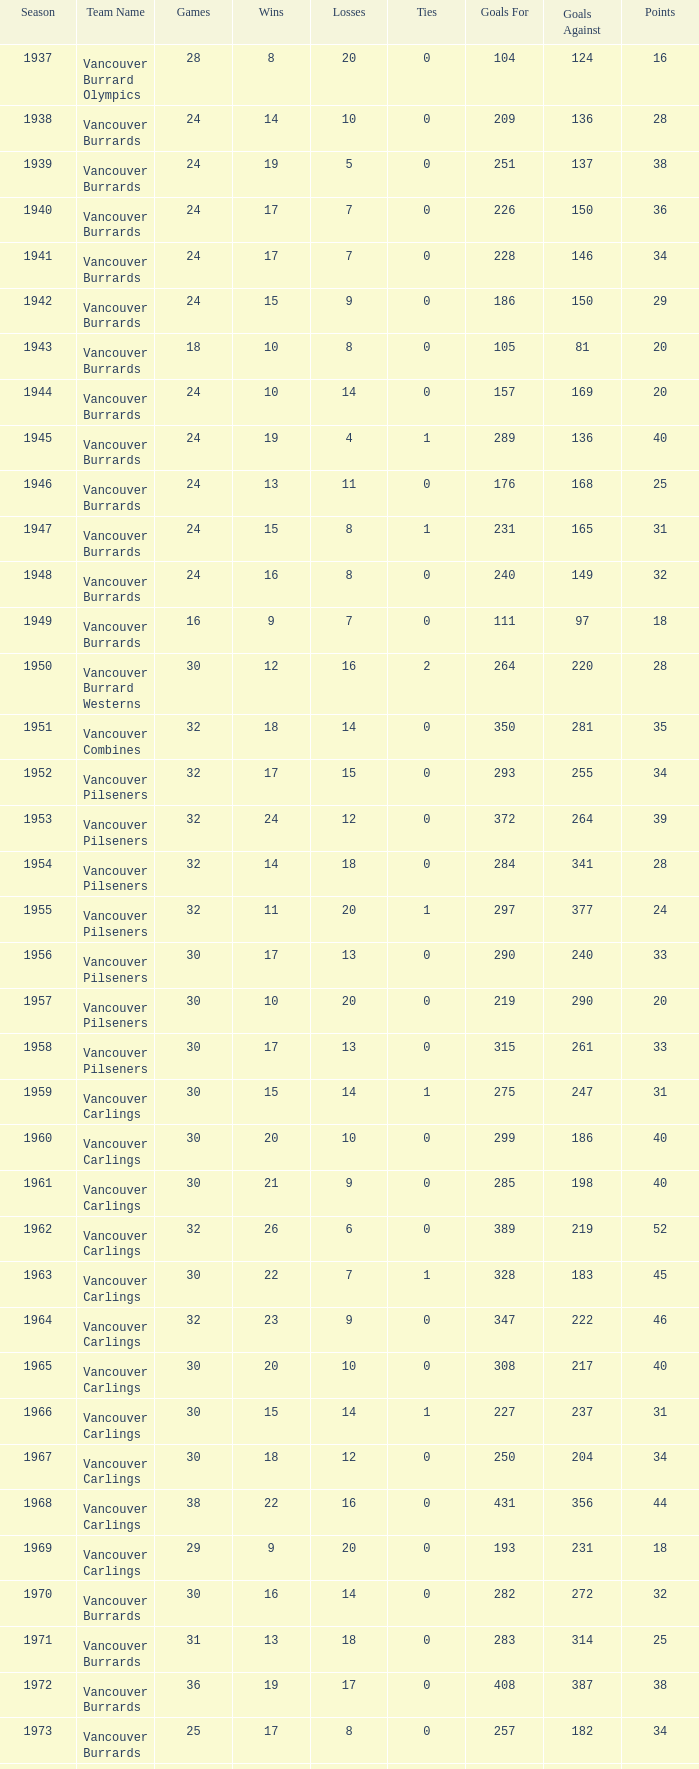What's the lowest number of points with fewer than 8 losses and fewer than 24 games for the vancouver burrards? 18.0. 